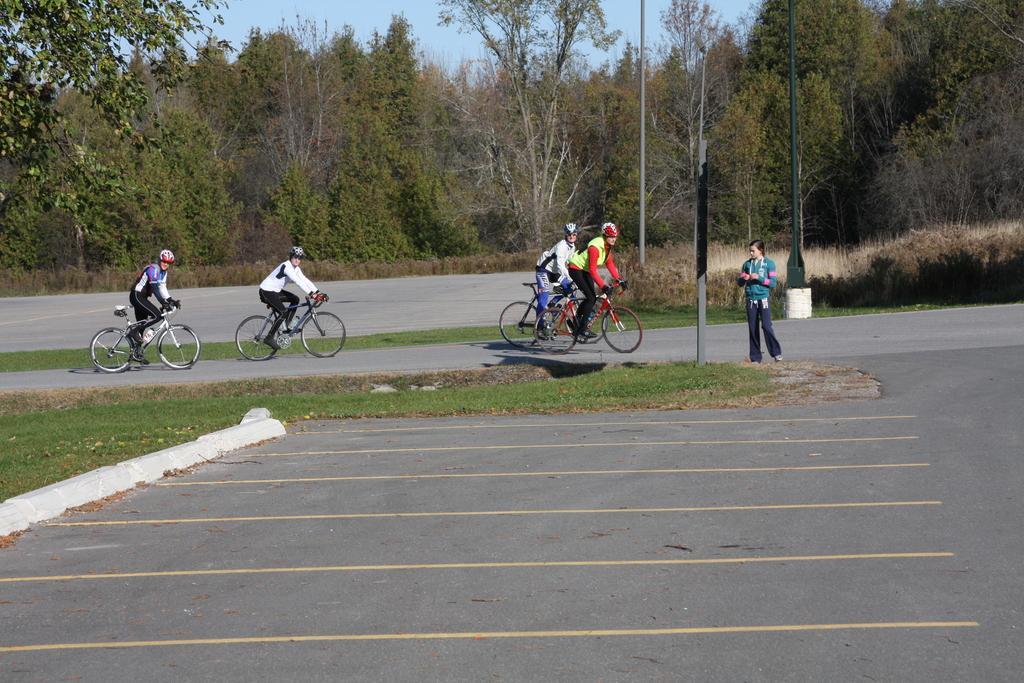Please provide a concise description of this image. In this picture we see few people riding bicycles and they wore helmets on their heads and a woman standing on the road and we see couple of poles and trees and a blue sky. 